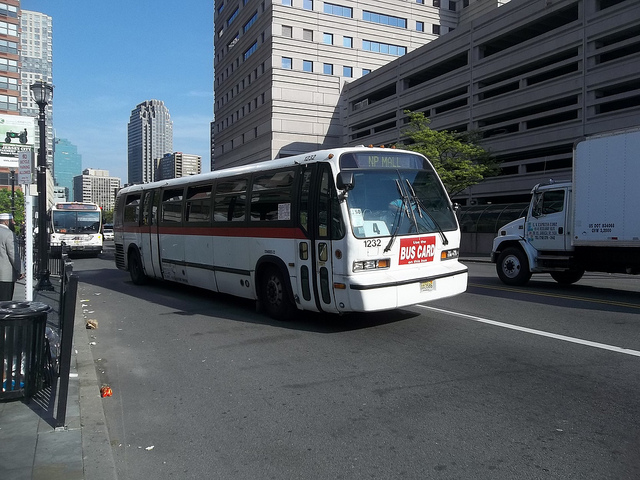Extract all visible text content from this image. MALL BUS CARD 1232 